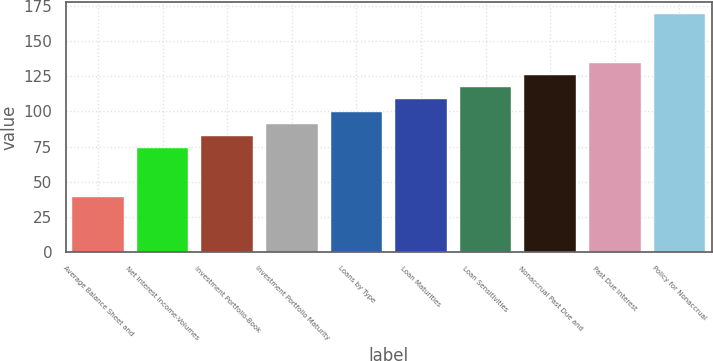<chart> <loc_0><loc_0><loc_500><loc_500><bar_chart><fcel>Average Balance Sheet and<fcel>Net Interest Income-Volumes<fcel>Investment Portfolio-Book<fcel>Investment Portfolio Maturity<fcel>Loans by Type<fcel>Loan Maturities<fcel>Loan Sensitivities<fcel>Nonaccrual Past Due and<fcel>Past Due Interest<fcel>Policy for Nonaccrual<nl><fcel>39<fcel>73.8<fcel>82.5<fcel>91.2<fcel>99.9<fcel>108.6<fcel>117.3<fcel>126<fcel>134.7<fcel>169.5<nl></chart> 